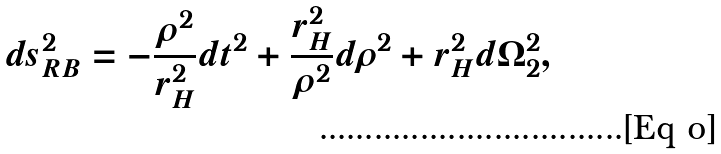<formula> <loc_0><loc_0><loc_500><loc_500>d s _ { R B } ^ { 2 } = - \frac { \rho ^ { 2 } } { r _ { H } ^ { 2 } } d t ^ { 2 } + \frac { r _ { H } ^ { 2 } } { \rho ^ { 2 } } d \rho ^ { 2 } + r _ { H } ^ { 2 } d \Omega _ { 2 } ^ { 2 } ,</formula> 